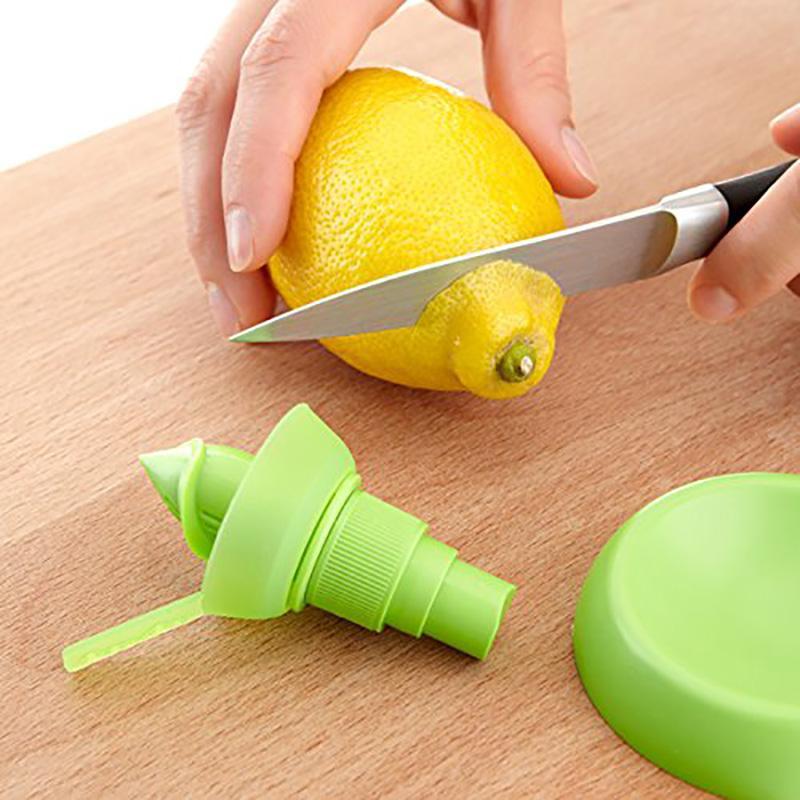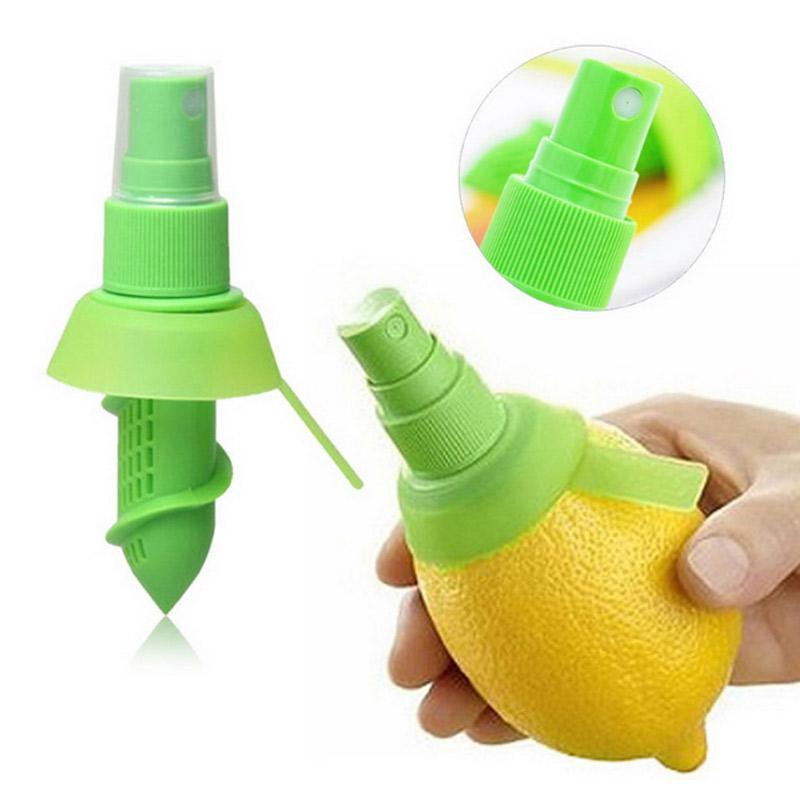The first image is the image on the left, the second image is the image on the right. For the images shown, is this caption "A person is holding the lemon in the image on the right." true? Answer yes or no. Yes. The first image is the image on the left, the second image is the image on the right. Analyze the images presented: Is the assertion "In one of the images, a whole lemon is being cut with a knife." valid? Answer yes or no. Yes. The first image is the image on the left, the second image is the image on the right. For the images displayed, is the sentence "An image contains a lemon being sliced by a knife." factually correct? Answer yes or no. Yes. 